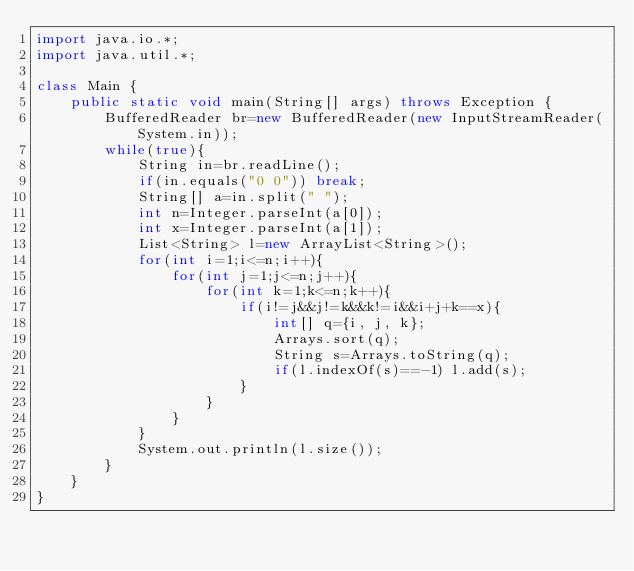<code> <loc_0><loc_0><loc_500><loc_500><_Java_>import java.io.*;
import java.util.*;

class Main {
	public static void main(String[] args) throws Exception {
		BufferedReader br=new BufferedReader(new InputStreamReader(System.in));
        while(true){
        	String in=br.readLine();
			if(in.equals("0 0")) break;
            String[] a=in.split(" ");
            int n=Integer.parseInt(a[0]);
            int x=Integer.parseInt(a[1]);
            List<String> l=new ArrayList<String>(); 
        	for(int i=1;i<=n;i++){
            	for(int j=1;j<=n;j++){
                	for(int k=1;k<=n;k++){
                		if(i!=j&&j!=k&&k!=i&&i+j+k==x){
                			int[] q={i, j, k};
                			Arrays.sort(q);
                			String s=Arrays.toString(q);
                			if(l.indexOf(s)==-1) l.add(s);
                		}
                	}
            	}
        	}
        	System.out.println(l.size());
        }
	}
}</code> 